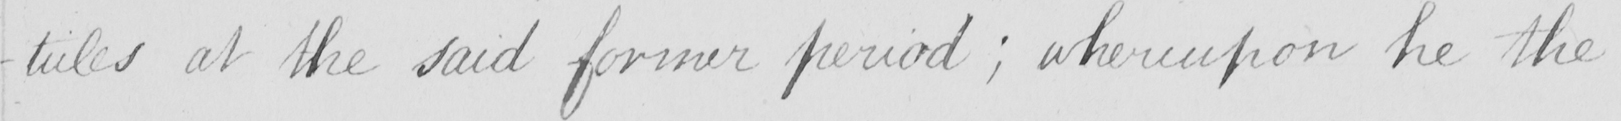What text is written in this handwritten line? -ticles at the said former period  ; whereupon he the 